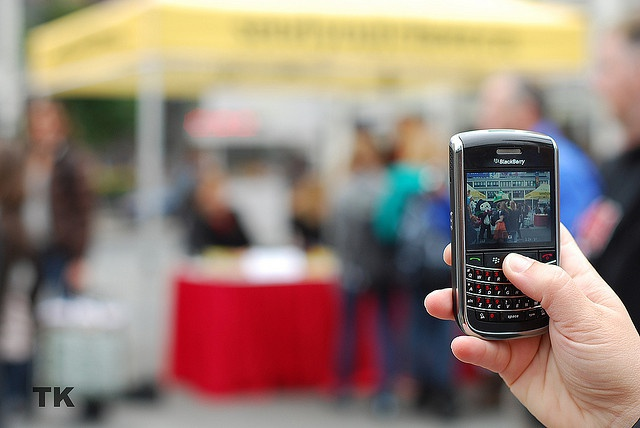Describe the objects in this image and their specific colors. I can see people in lightgray, tan, and brown tones, cell phone in lightgray, black, gray, darkgray, and blue tones, people in lightgray, gray, and black tones, people in lightgray, black, gray, and darkgray tones, and people in lightgray, black, lightpink, darkgray, and gray tones in this image. 